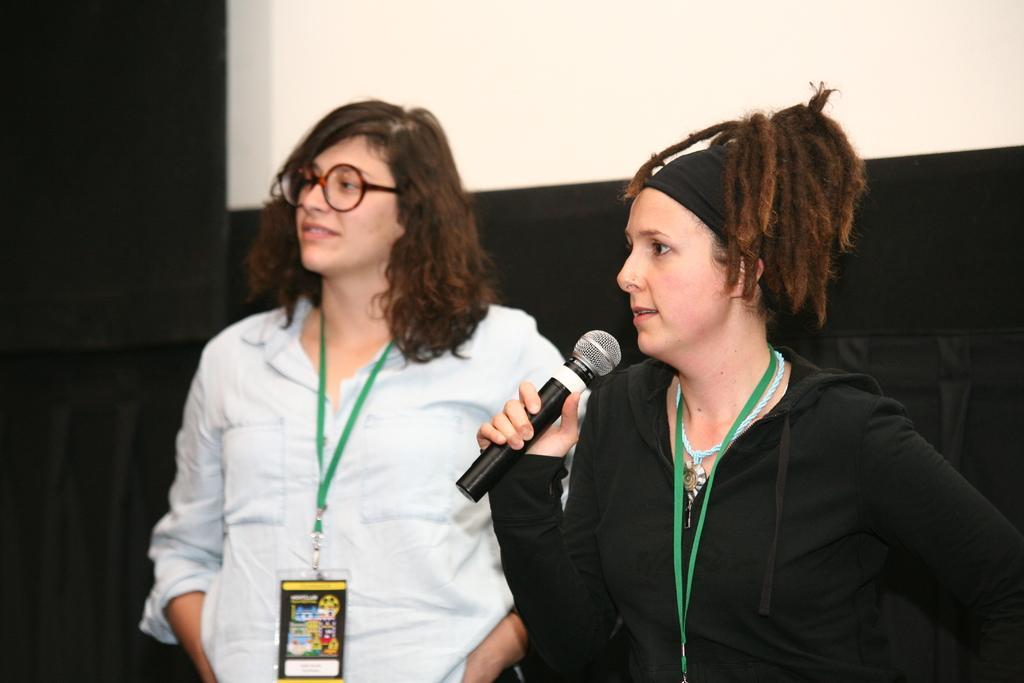Can you describe this image briefly? The women in the right is holding a mic in her hand and there is another woman standing beside her. 